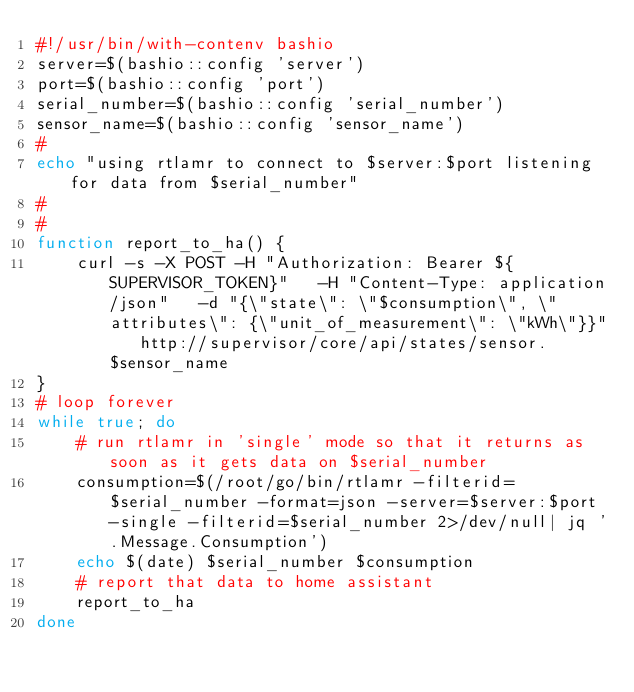<code> <loc_0><loc_0><loc_500><loc_500><_Bash_>#!/usr/bin/with-contenv bashio
server=$(bashio::config 'server')
port=$(bashio::config 'port')
serial_number=$(bashio::config 'serial_number')
sensor_name=$(bashio::config 'sensor_name')
#
echo "using rtlamr to connect to $server:$port listening for data from $serial_number"
#
#
function report_to_ha() {
    curl -s -X POST -H "Authorization: Bearer ${SUPERVISOR_TOKEN}"   -H "Content-Type: application/json"   -d "{\"state\": \"$consumption\", \"attributes\": {\"unit_of_measurement\": \"kWh\"}}"   http://supervisor/core/api/states/sensor.$sensor_name
}
# loop forever
while true; do
    # run rtlamr in 'single' mode so that it returns as soon as it gets data on $serial_number
    consumption=$(/root/go/bin/rtlamr -filterid=$serial_number -format=json -server=$server:$port -single -filterid=$serial_number 2>/dev/null| jq '.Message.Consumption')
    echo $(date) $serial_number $consumption
    # report that data to home assistant
    report_to_ha
done
</code> 